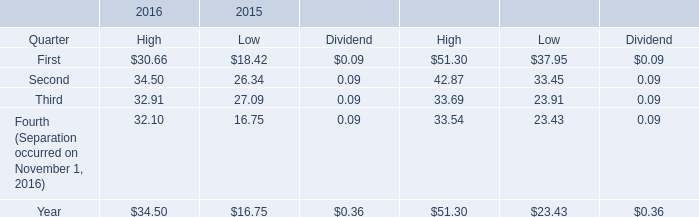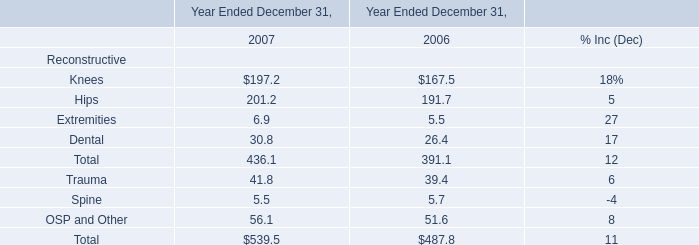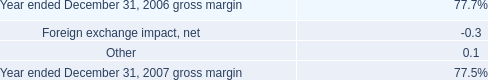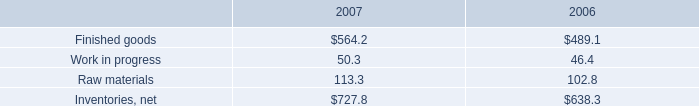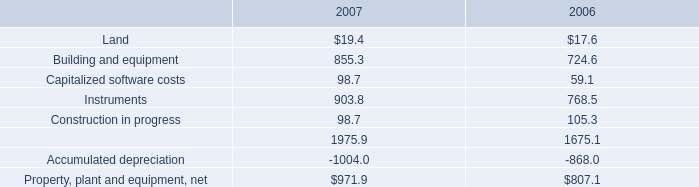As As the chart 4 shows,what is the value for the Instruments in 2007? 
Answer: 903.8. 